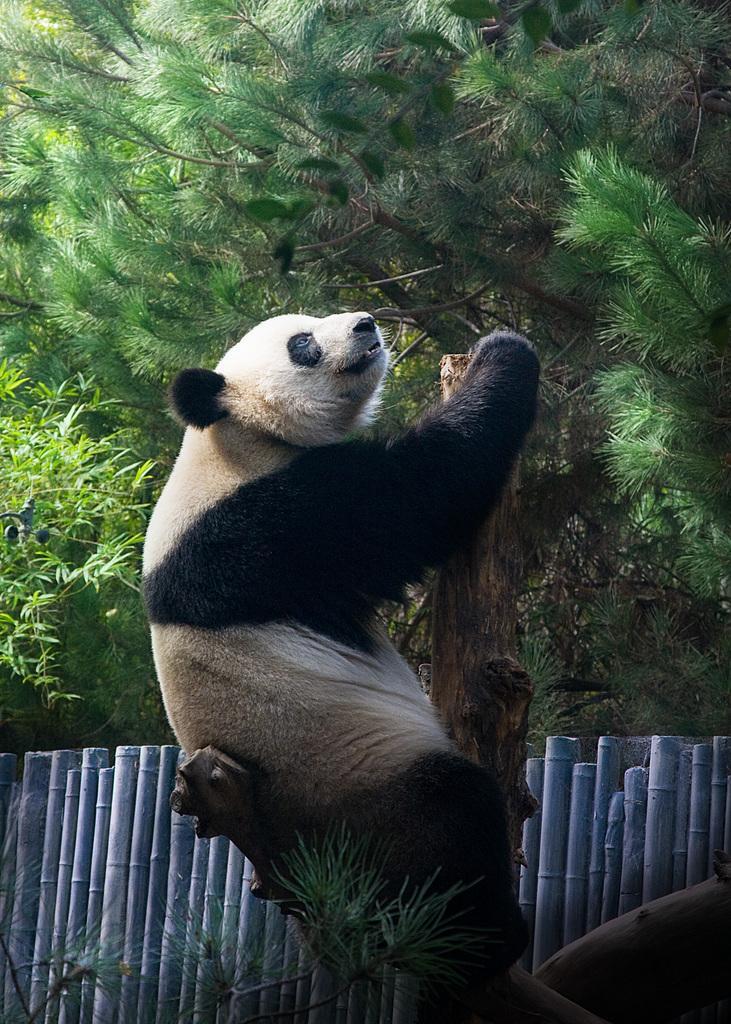Describe this image in one or two sentences. In this image we can see a panda sitting on a tree and there is a wooden fence and we can see some trees in the background. 